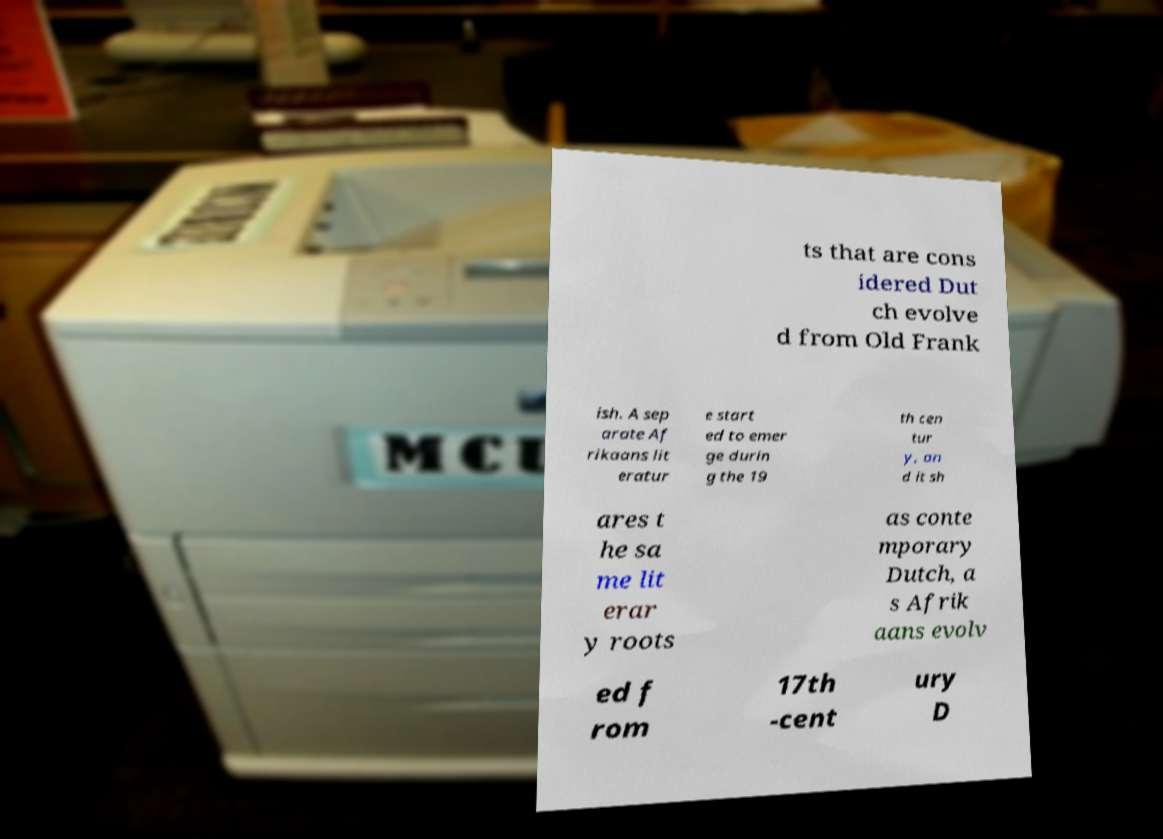Could you assist in decoding the text presented in this image and type it out clearly? ts that are cons idered Dut ch evolve d from Old Frank ish. A sep arate Af rikaans lit eratur e start ed to emer ge durin g the 19 th cen tur y, an d it sh ares t he sa me lit erar y roots as conte mporary Dutch, a s Afrik aans evolv ed f rom 17th -cent ury D 